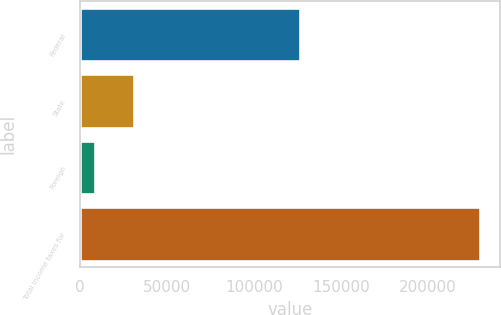<chart> <loc_0><loc_0><loc_500><loc_500><bar_chart><fcel>Federal<fcel>State<fcel>Foreign<fcel>Total income taxes for<nl><fcel>126773<fcel>30792.5<fcel>8647<fcel>230102<nl></chart> 